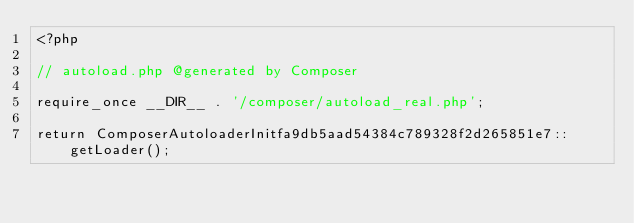Convert code to text. <code><loc_0><loc_0><loc_500><loc_500><_PHP_><?php

// autoload.php @generated by Composer

require_once __DIR__ . '/composer/autoload_real.php';

return ComposerAutoloaderInitfa9db5aad54384c789328f2d265851e7::getLoader();
</code> 